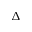Convert formula to latex. <formula><loc_0><loc_0><loc_500><loc_500>\Delta</formula> 